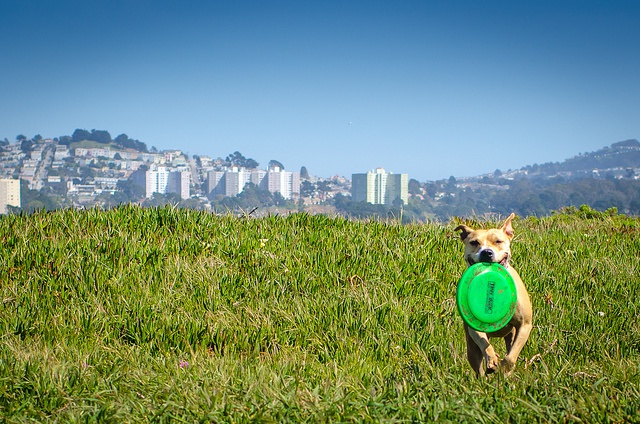Describe the objects in this image and their specific colors. I can see dog in blue, black, khaki, olive, and tan tones and frisbee in blue, lightgreen, lime, and green tones in this image. 